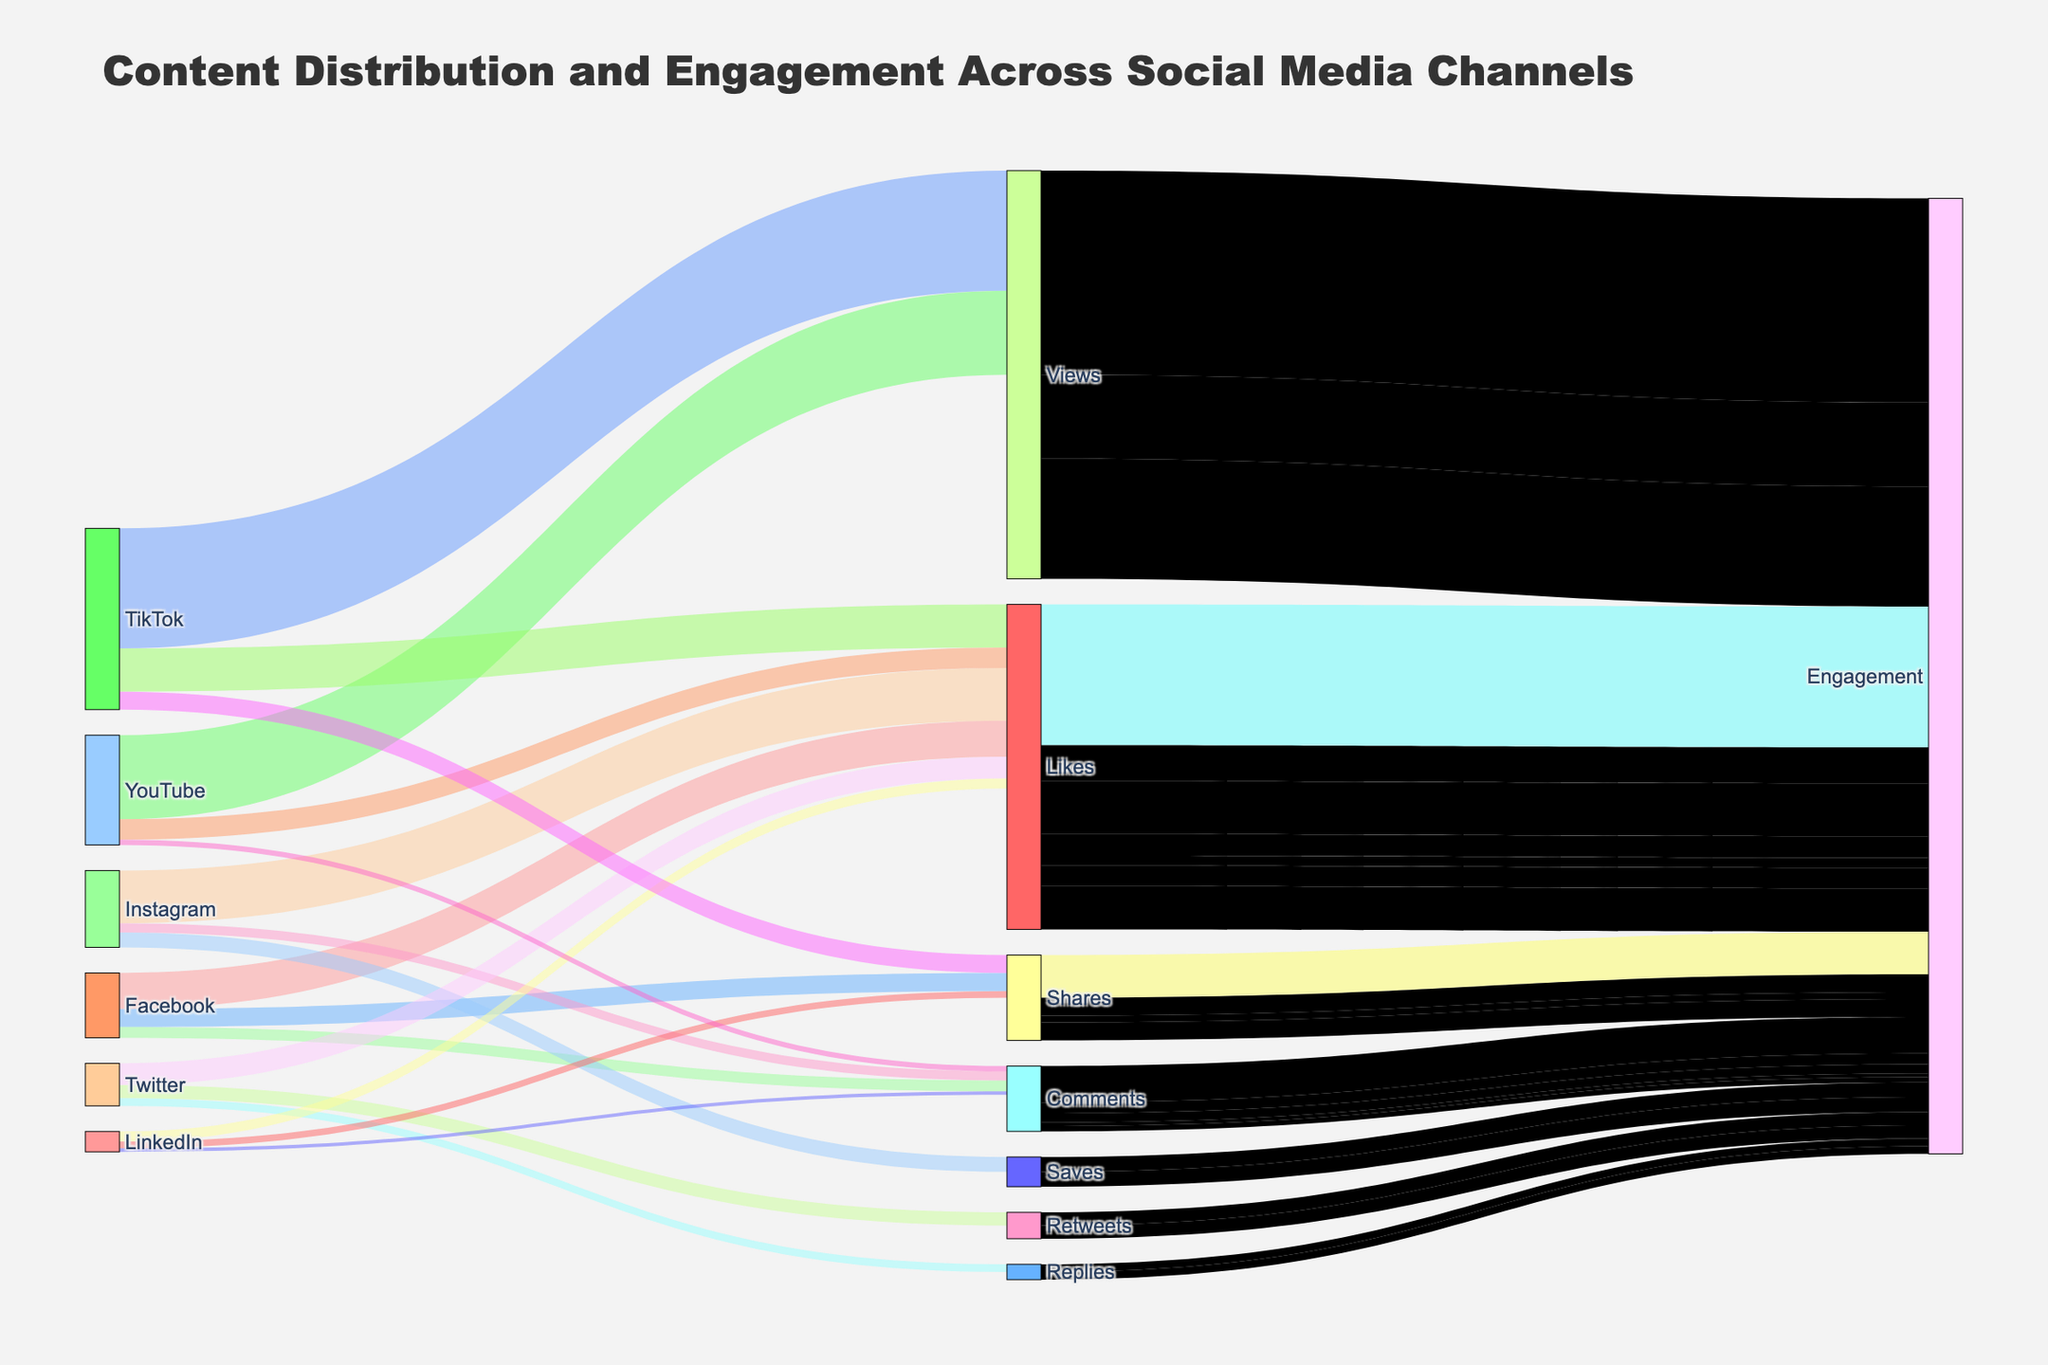How many total likes were recorded across all social media channels? Add the values for Likes from Facebook (15000), Instagram (22000), Twitter (9000), LinkedIn (4200), YouTube (8500), and TikTok (18000). So, 15000 + 22000 + 9000 + 4200 + 8500 + 18000 = 76700.
Answer: 76700 Which social media channel generated the most engagement through comments? Compare the comment values for each social media channel: Facebook (4500), Instagram (3800), LinkedIn (1500), YouTube (2200), Twitter (3200). Facebook has the highest value with 4500 comments.
Answer: Facebook What's the combined engagement value for shares and retweets? Add the engagement values for shares (17800) and retweets (5500). So, 17800 + 5500 = 23300.
Answer: 23300 Which social media channel had the highest value for a single type of engagement, and what was it? Check the individual engagement values for each channel. TikTok had 50000 views, which is the highest single type of engagement.
Answer: TikTok, 50000 views How does the value of Instagram saves compare to LinkedIn shares? Compare the values for Instagram saves (6200) and LinkedIn shares (2800). Instagram saves (6200) is higher than LinkedIn shares (2800).
Answer: Instagram saves are higher What is the total value of engagements coming from views? Add the engagement values for views from YouTube (35000) and TikTok (50000). So, 35000 + 50000 = 85000.
Answer: 85000 Which social media platform contributed the most to overall engagement? Sum all engagement contributions by each platform. TikTok’s values are highest overall with views (50000) being a significant contributor.
Answer: TikTok What's the average number of comments across all channels? Add up all the comments from Facebook (4500), Instagram (3800), LinkedIn (1500), YouTube (2200), Twitter (3200) which gives 15200. Then divide by the number of channels (5). So, 15200 / 5 = 3040.
Answer: 3040 Does Twitter have more likes or retweets? Compare the values for Twitter's likes (9000) to retweets (5500). Twitter has more likes (9000).
Answer: More likes 